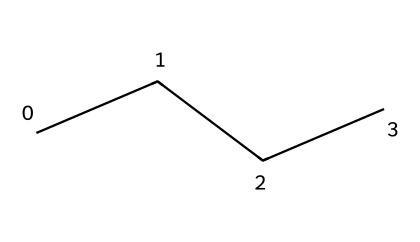What is the name of the chemical represented by this structure? The provided SMILES representation corresponds to a straight-chain alkane with four carbon atoms connected by single bonds, which is known as butane.
Answer: butane How many carbon atoms are in the molecule? In the SMILES representation "CCCC", each 'C' signifies a carbon atom. There are four 'C's, indicating that there are four carbon atoms in total.
Answer: four How many hydrogen atoms are in the molecule? Butane is a saturated hydrocarbon, meaning it follows the formula CnH(2n+2). For four carbon atoms (n=4), the hydrogen count is calculated as 2(4)+2=10. Thus, butane contains ten hydrogen atoms.
Answer: ten What type of bonds are present between the carbon atoms? The SMILES representation shows that all bonds between the carbon atoms are single bonds, as there are no double or triple bonds indicated. This is typical for alkanes, where only single covalent bonds are formed.
Answer: single Is butane a flammable liquid? Butane is a well-known flammable liquid used in portable grills and other cooking devices due to its ease of vaporization and combustion. It is classified as flammable based on its physical properties.
Answer: yes What is the state of butane at room temperature? Butane, being an alkane with four carbon atoms, is a gas at room temperature and atmospheric pressure, although it can be liquefied under pressure.
Answer: gas 